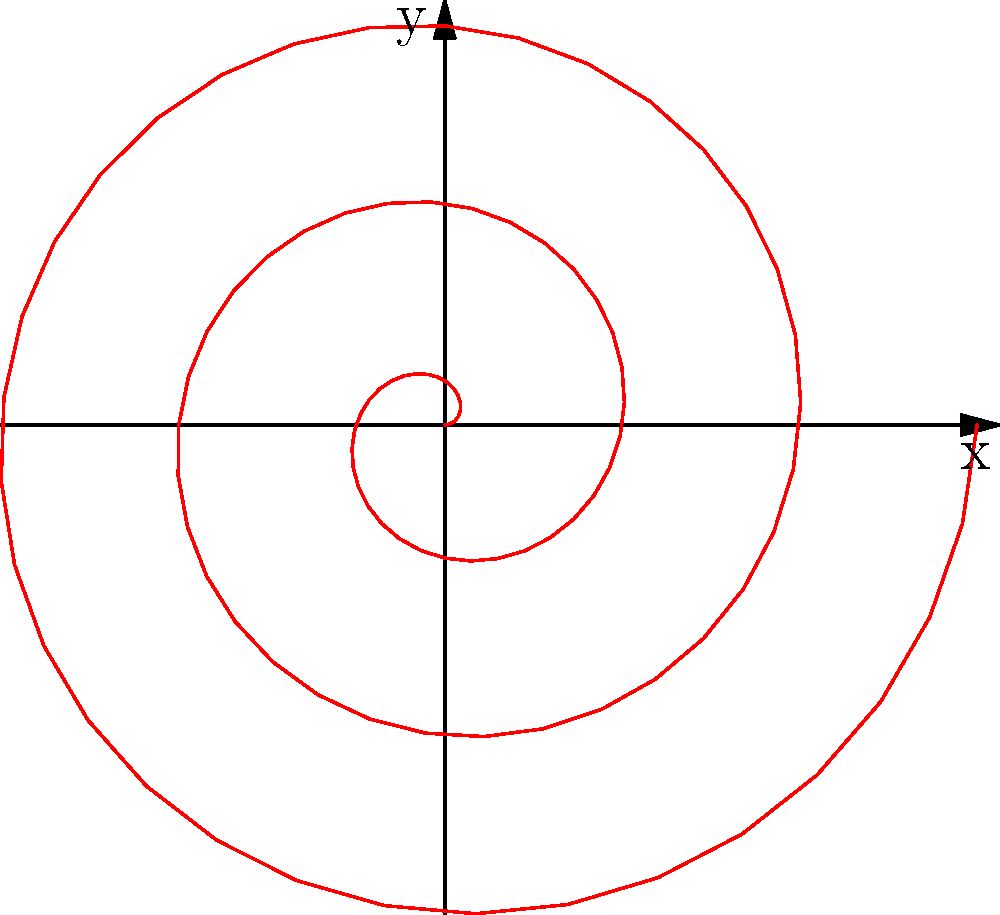In the given polar coordinate plot, which equation best represents the spiral pattern shown?

A) $r = \theta$
B) $r = 0.1\theta$
C) $r = \theta^2$
D) $r = e^\theta$ To determine the correct equation for the spiral pattern, let's analyze the characteristics of the curve:

1. The spiral starts at the origin and gradually moves outward as $\theta$ increases.
2. The spacing between consecutive turns appears to be constant.
3. The curve completes roughly 3 full rotations.

These observations suggest a linear relationship between $r$ and $\theta$. Let's examine each option:

A) $r = \theta$: This would create a spiral that expands too quickly.
B) $r = 0.1\theta$: This creates a spiral that expands more slowly, which matches the given plot.
C) $r = \theta^2$: This would create a spiral that expands much faster than shown.
D) $r = e^\theta$: This would create an exponential spiral, expanding much faster than shown.

The equation $r = 0.1\theta$ best fits the observed pattern. It creates a spiral with constant spacing between turns and a gradual outward expansion, matching the plot.

To verify:
- The plot shows about 3 full rotations, which corresponds to $6\pi$ radians.
- At $\theta = 6\pi$, $r = 0.1 * 6\pi \approx 1.88$, which matches the maximum radius in the plot.

Therefore, the correct answer is B) $r = 0.1\theta$.
Answer: B) $r = 0.1\theta$ 